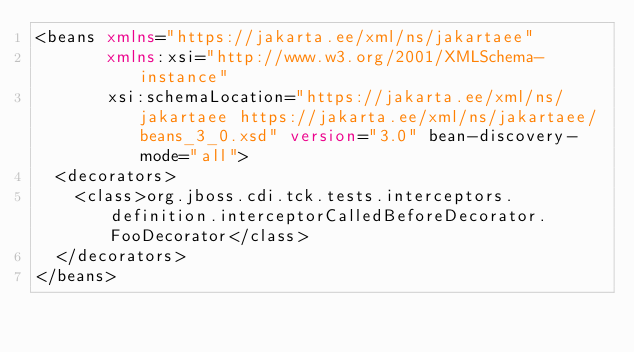Convert code to text. <code><loc_0><loc_0><loc_500><loc_500><_XML_><beans xmlns="https://jakarta.ee/xml/ns/jakartaee"
       xmlns:xsi="http://www.w3.org/2001/XMLSchema-instance"
       xsi:schemaLocation="https://jakarta.ee/xml/ns/jakartaee https://jakarta.ee/xml/ns/jakartaee/beans_3_0.xsd" version="3.0" bean-discovery-mode="all">
  <decorators>
    <class>org.jboss.cdi.tck.tests.interceptors.definition.interceptorCalledBeforeDecorator.FooDecorator</class>
  </decorators>
</beans>
</code> 